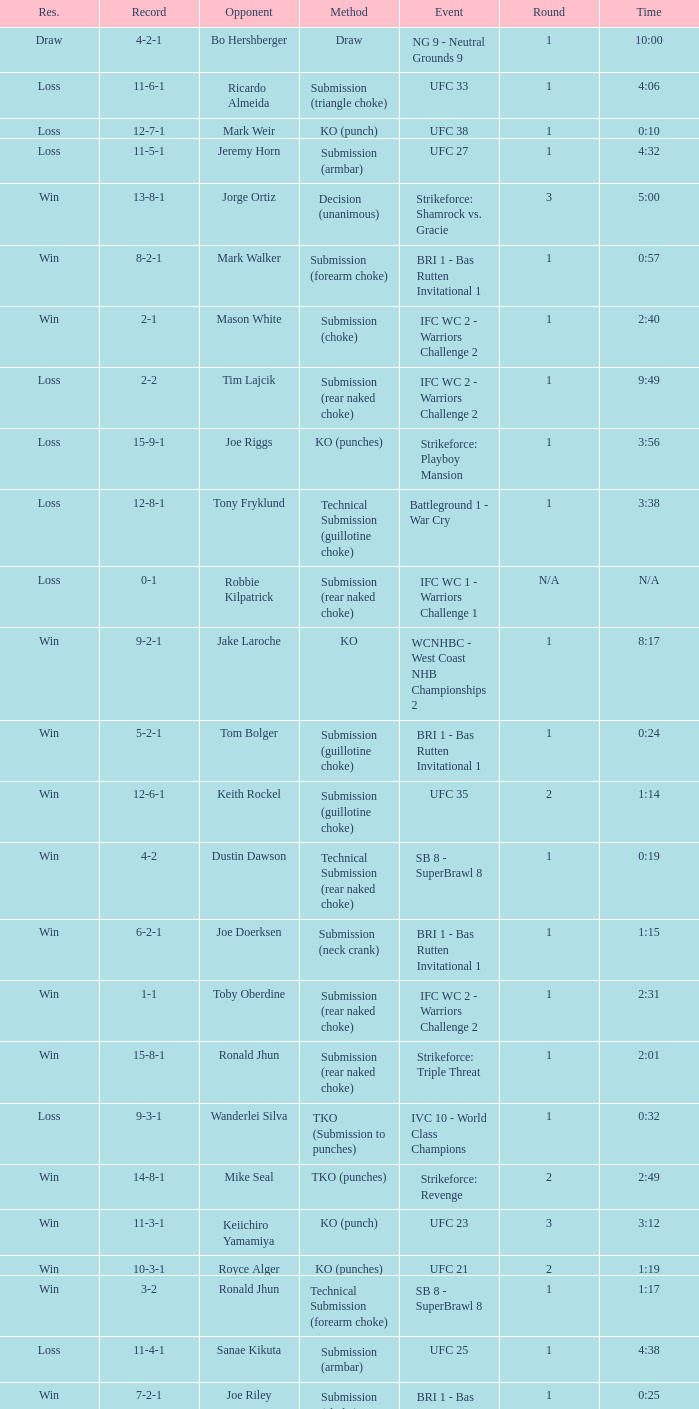What is the record during the event, UFC 27? 11-5-1. 